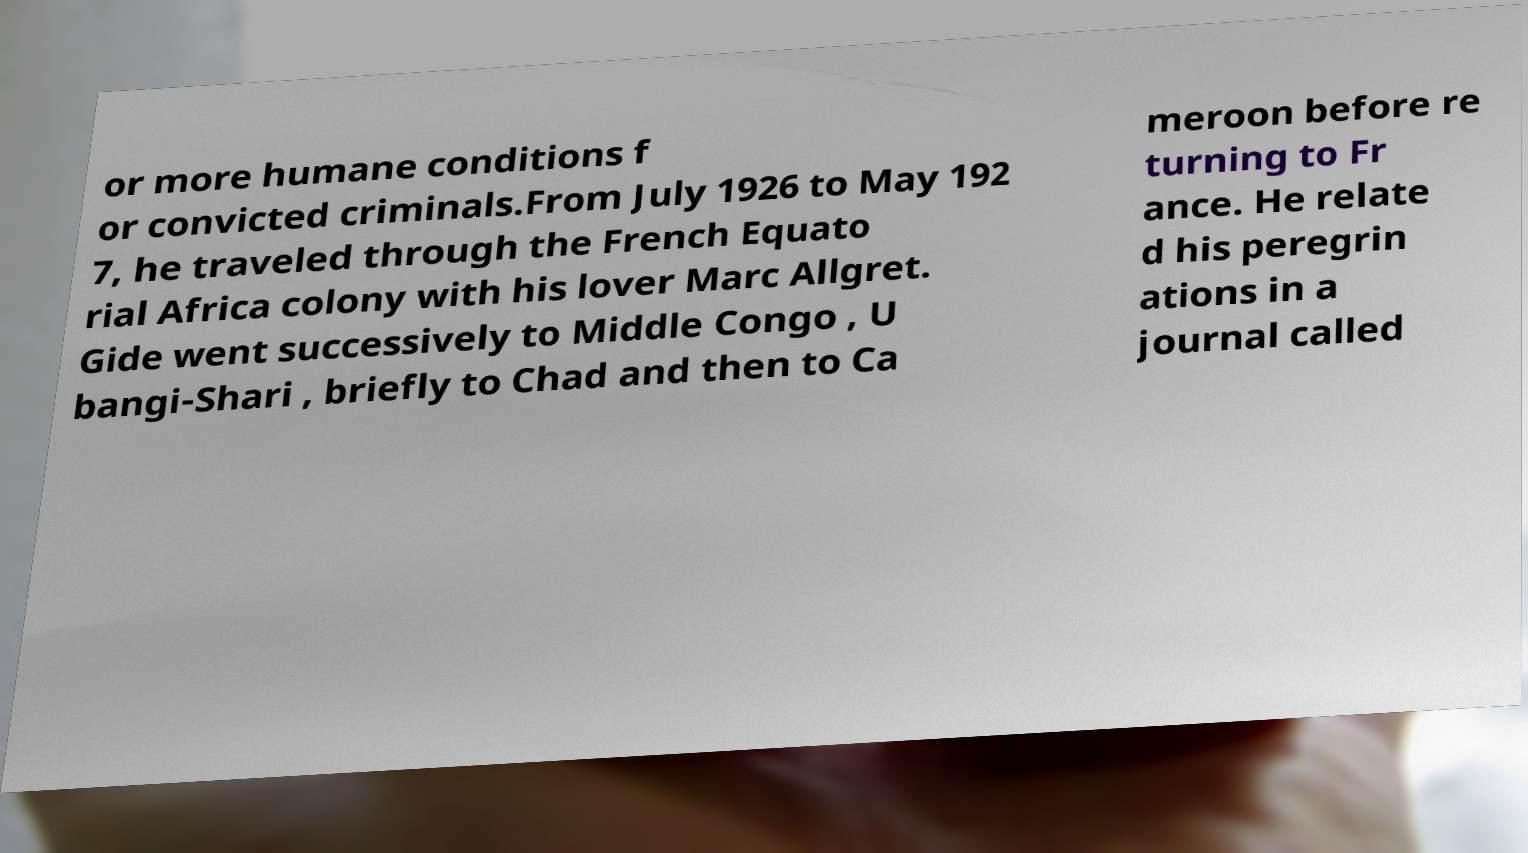What messages or text are displayed in this image? I need them in a readable, typed format. or more humane conditions f or convicted criminals.From July 1926 to May 192 7, he traveled through the French Equato rial Africa colony with his lover Marc Allgret. Gide went successively to Middle Congo , U bangi-Shari , briefly to Chad and then to Ca meroon before re turning to Fr ance. He relate d his peregrin ations in a journal called 